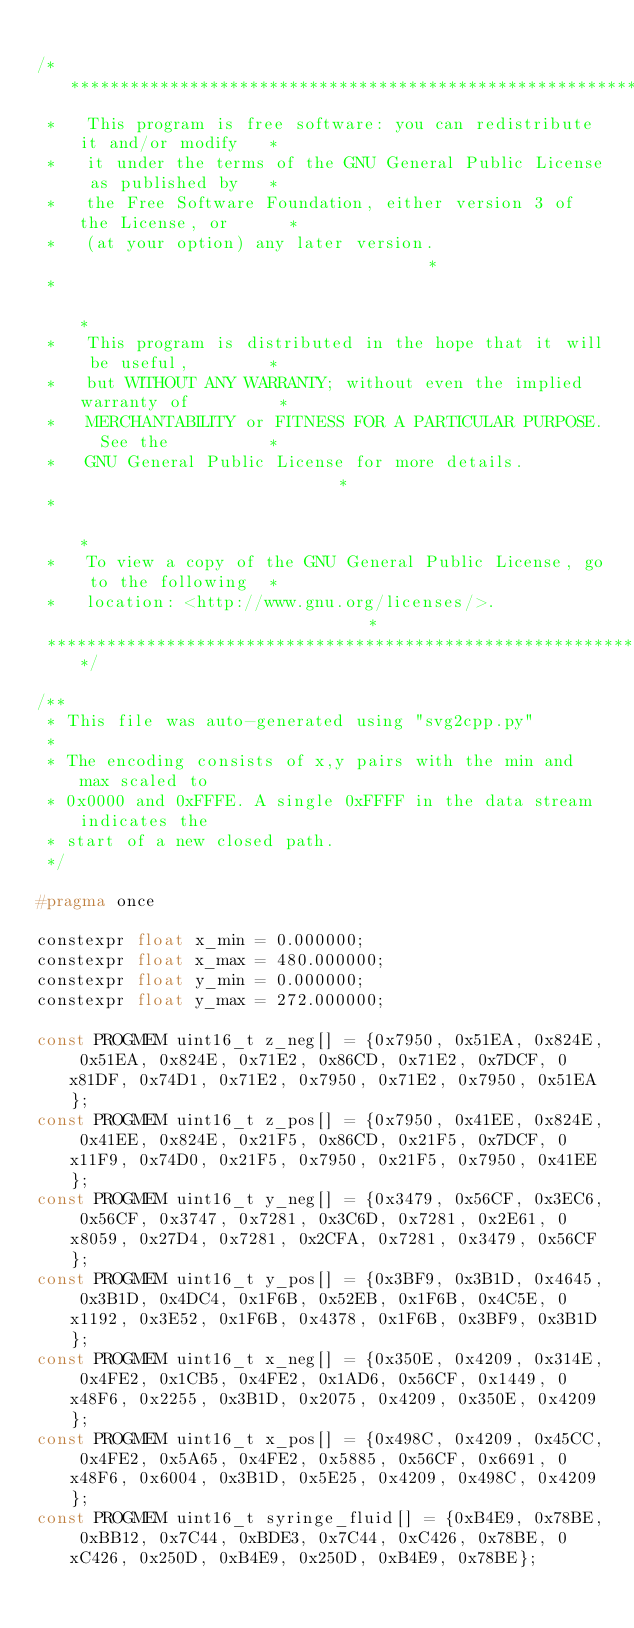Convert code to text. <code><loc_0><loc_0><loc_500><loc_500><_C_>
/****************************************************************************
 *   This program is free software: you can redistribute it and/or modify   *
 *   it under the terms of the GNU General Public License as published by   *
 *   the Free Software Foundation, either version 3 of the License, or      *
 *   (at your option) any later version.                                    *
 *                                                                          *
 *   This program is distributed in the hope that it will be useful,        *
 *   but WITHOUT ANY WARRANTY; without even the implied warranty of         *
 *   MERCHANTABILITY or FITNESS FOR A PARTICULAR PURPOSE.  See the          *
 *   GNU General Public License for more details.                           *
 *                                                                          *
 *   To view a copy of the GNU General Public License, go to the following  *
 *   location: <http://www.gnu.org/licenses/>.                              *
 ****************************************************************************/

/**
 * This file was auto-generated using "svg2cpp.py"
 *
 * The encoding consists of x,y pairs with the min and max scaled to
 * 0x0000 and 0xFFFE. A single 0xFFFF in the data stream indicates the
 * start of a new closed path.
 */

#pragma once

constexpr float x_min = 0.000000;
constexpr float x_max = 480.000000;
constexpr float y_min = 0.000000;
constexpr float y_max = 272.000000;

const PROGMEM uint16_t z_neg[] = {0x7950, 0x51EA, 0x824E, 0x51EA, 0x824E, 0x71E2, 0x86CD, 0x71E2, 0x7DCF, 0x81DF, 0x74D1, 0x71E2, 0x7950, 0x71E2, 0x7950, 0x51EA};
const PROGMEM uint16_t z_pos[] = {0x7950, 0x41EE, 0x824E, 0x41EE, 0x824E, 0x21F5, 0x86CD, 0x21F5, 0x7DCF, 0x11F9, 0x74D0, 0x21F5, 0x7950, 0x21F5, 0x7950, 0x41EE};
const PROGMEM uint16_t y_neg[] = {0x3479, 0x56CF, 0x3EC6, 0x56CF, 0x3747, 0x7281, 0x3C6D, 0x7281, 0x2E61, 0x8059, 0x27D4, 0x7281, 0x2CFA, 0x7281, 0x3479, 0x56CF};
const PROGMEM uint16_t y_pos[] = {0x3BF9, 0x3B1D, 0x4645, 0x3B1D, 0x4DC4, 0x1F6B, 0x52EB, 0x1F6B, 0x4C5E, 0x1192, 0x3E52, 0x1F6B, 0x4378, 0x1F6B, 0x3BF9, 0x3B1D};
const PROGMEM uint16_t x_neg[] = {0x350E, 0x4209, 0x314E, 0x4FE2, 0x1CB5, 0x4FE2, 0x1AD6, 0x56CF, 0x1449, 0x48F6, 0x2255, 0x3B1D, 0x2075, 0x4209, 0x350E, 0x4209};
const PROGMEM uint16_t x_pos[] = {0x498C, 0x4209, 0x45CC, 0x4FE2, 0x5A65, 0x4FE2, 0x5885, 0x56CF, 0x6691, 0x48F6, 0x6004, 0x3B1D, 0x5E25, 0x4209, 0x498C, 0x4209};
const PROGMEM uint16_t syringe_fluid[] = {0xB4E9, 0x78BE, 0xBB12, 0x7C44, 0xBDE3, 0x7C44, 0xC426, 0x78BE, 0xC426, 0x250D, 0xB4E9, 0x250D, 0xB4E9, 0x78BE};</code> 